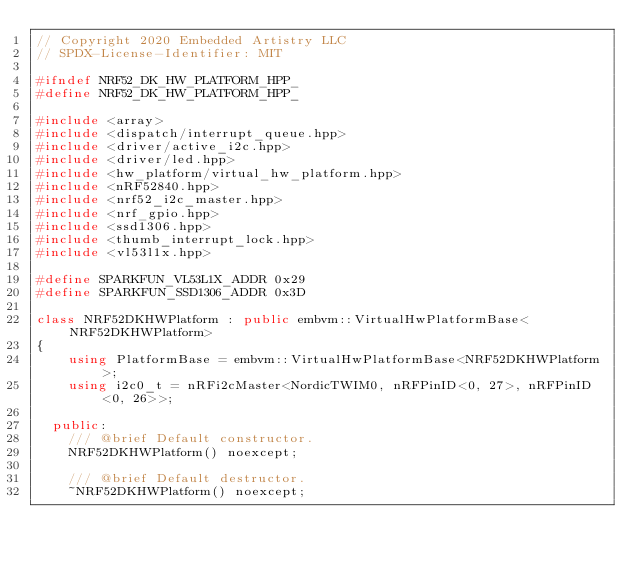<code> <loc_0><loc_0><loc_500><loc_500><_C++_>// Copyright 2020 Embedded Artistry LLC
// SPDX-License-Identifier: MIT

#ifndef NRF52_DK_HW_PLATFORM_HPP_
#define NRF52_DK_HW_PLATFORM_HPP_

#include <array>
#include <dispatch/interrupt_queue.hpp>
#include <driver/active_i2c.hpp>
#include <driver/led.hpp>
#include <hw_platform/virtual_hw_platform.hpp>
#include <nRF52840.hpp>
#include <nrf52_i2c_master.hpp>
#include <nrf_gpio.hpp>
#include <ssd1306.hpp>
#include <thumb_interrupt_lock.hpp>
#include <vl53l1x.hpp>

#define SPARKFUN_VL53L1X_ADDR 0x29
#define SPARKFUN_SSD1306_ADDR 0x3D

class NRF52DKHWPlatform : public embvm::VirtualHwPlatformBase<NRF52DKHWPlatform>
{
	using PlatformBase = embvm::VirtualHwPlatformBase<NRF52DKHWPlatform>;
	using i2c0_t = nRFi2cMaster<NordicTWIM0, nRFPinID<0, 27>, nRFPinID<0, 26>>;

  public:
	/// @brief Default constructor.
	NRF52DKHWPlatform() noexcept;

	/// @brief Default destructor.
	~NRF52DKHWPlatform() noexcept;
</code> 